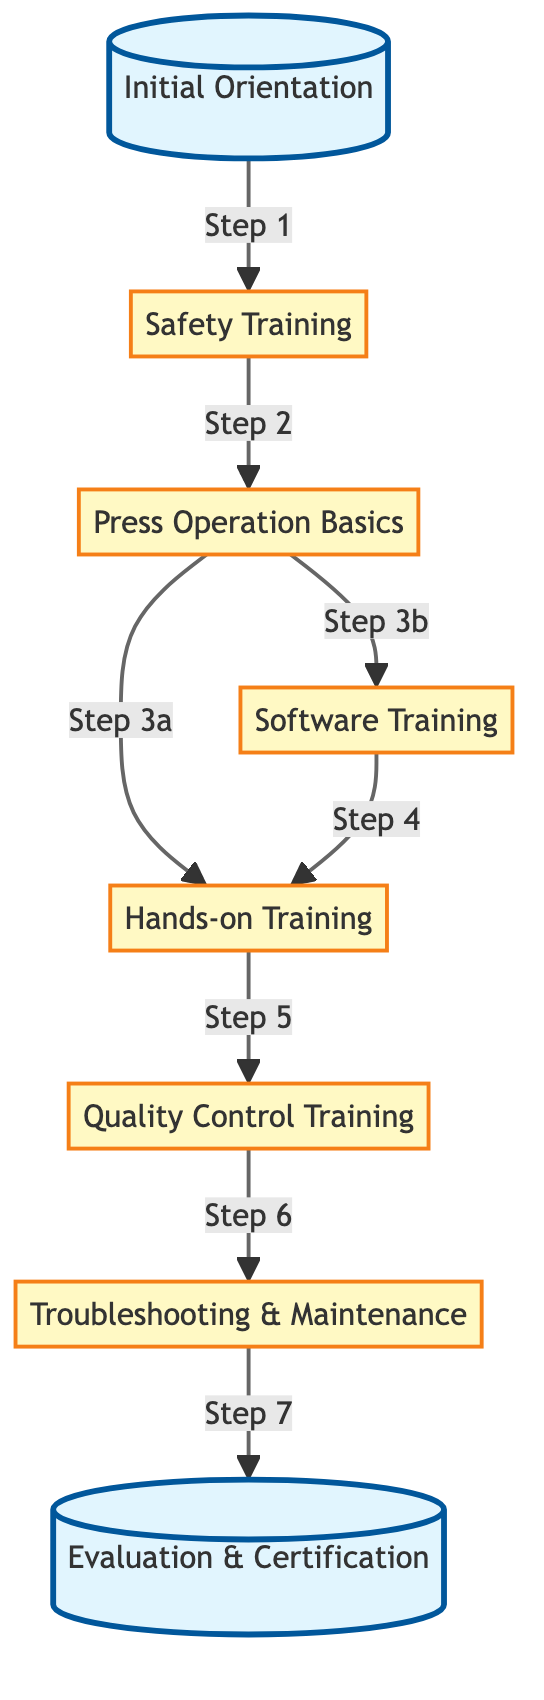What is the first step in the training process? The diagram indicates that the first step in the training process is "Initial Orientation," which is the starting point before any other activity can occur.
Answer: Initial Orientation How many training nodes are present in the diagram? By counting each distinct step or training element in the diagram, we identify eight nodes, which represent the various stages of the training process.
Answer: 8 What two training activities follow 'Press Operation Basics'? According to the diagram, 'Press Operation Basics' leads to both 'Hands-on Training' and 'Software Training' as subsequent activities in the process.
Answer: Hands-on Training, Software Training What is the last training step in the process? The diagram shows that the final step in the training process is 'Evaluation & Certification', which concludes the training once all other training sessions are completed.
Answer: Evaluation & Certification What is required after 'Quality Control Training'? The flow indicates that 'Troubleshooting & Maintenance' is the necessary next step after 'Quality Control Training', continuing the progression of training.
Answer: Troubleshooting & Maintenance Which step comes directly after 'Safety Training'? The diagram clearly outlines that 'Safety Training' is followed directly by 'Press Operation Basics', marking the transition from safety to operational training.
Answer: Press Operation Basics What step must be completed before evaluating the employee? The 'Troubleshooting & Maintenance' step must be completed before moving on to 'Evaluation & Certification', as shown in the flow of the training process.
Answer: Troubleshooting & Maintenance What is the relationship between 'Software Training' and 'Hands-on Training'? The relationship illustrated in the diagram demonstrates that 'Software Training' feeds into 'Hands-on Training', as trainees must learn the software before engaging in hands-on practices.
Answer: Software Training leads to Hands-on Training 